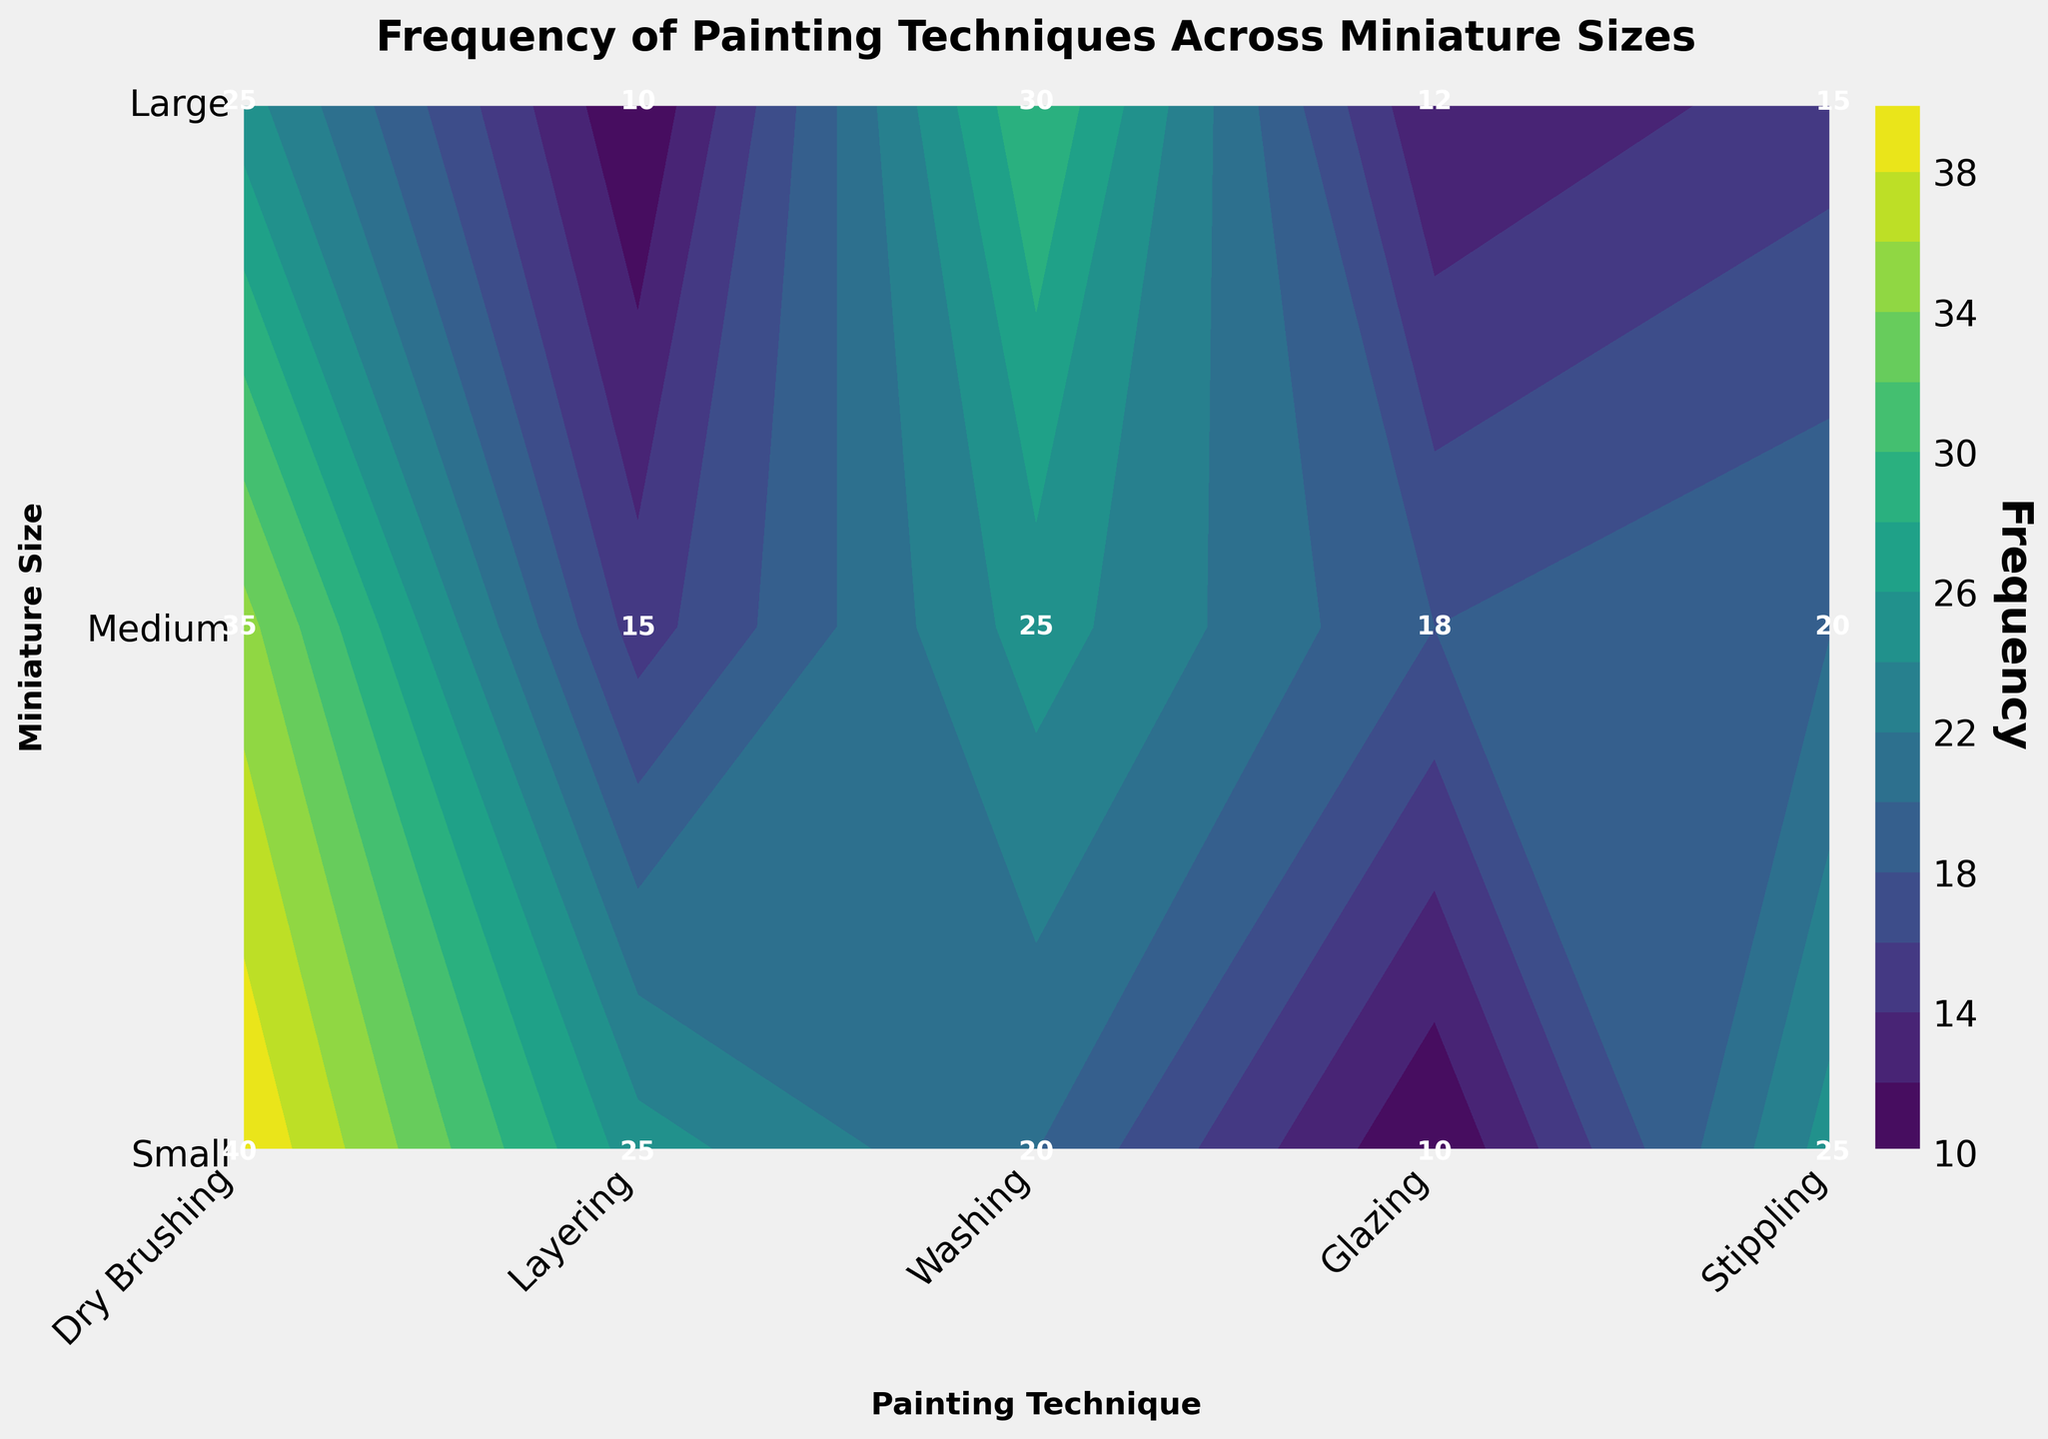What's the most frequently used painting technique for small miniatures? Find the row corresponding to "Small" on the y-axis and identify the highest number among the techniques. The highest value in this row is 30, which corresponds to "Layering".
Answer: Layering Which technique on medium miniatures is used less frequently than washing but more than stippling? Look at the row corresponding to "Medium". The "Washing" technique has a frequency of 20, and "Stippling" has 18. The only technique with a frequency between these two values is "Glazing" with a frequency of 15.
Answer: Glazing Is stippling more commonly used on medium miniatures than large miniatures? Compare the frequency of "Stippling" for Medium and Large sizes. Medium has a frequency of 18, while Large has a frequency of 10.
Answer: Yes Compare the frequency of washing for small miniatures to stippling for large miniatures. Which one is higher? Find the frequencies: Washing for Small is 15, and Stippling for Large is 10. Thus, Washing for Small is higher.
Answer: Washing for Small What is the average frequency of layering across all miniature sizes? Sum the frequencies for "Layering" across all sizes and divide by the number of sizes: (30 + 25 + 20) / 3 = 75 / 3 = 25.
Answer: 25 Which miniature size and technique combination has the lowest frequency? Identify the lowest number in the plot. It is 10, appearing in both Glazing for Small and Stippling for Large.
Answer: Glazing for Small or Stippling for Large 